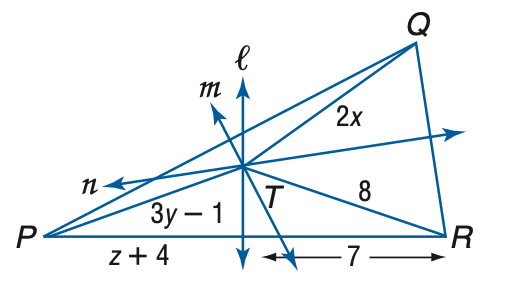Answer the mathemtical geometry problem and directly provide the correct option letter.
Question: Lines l, m, and n are perpendicular bisectors of \triangle P Q R and meet at T. If T Q = 2 x, P T = 3 y - 1, and T R = 8, find x.
Choices: A: 3 B: 4 C: 5 D: 6 B 